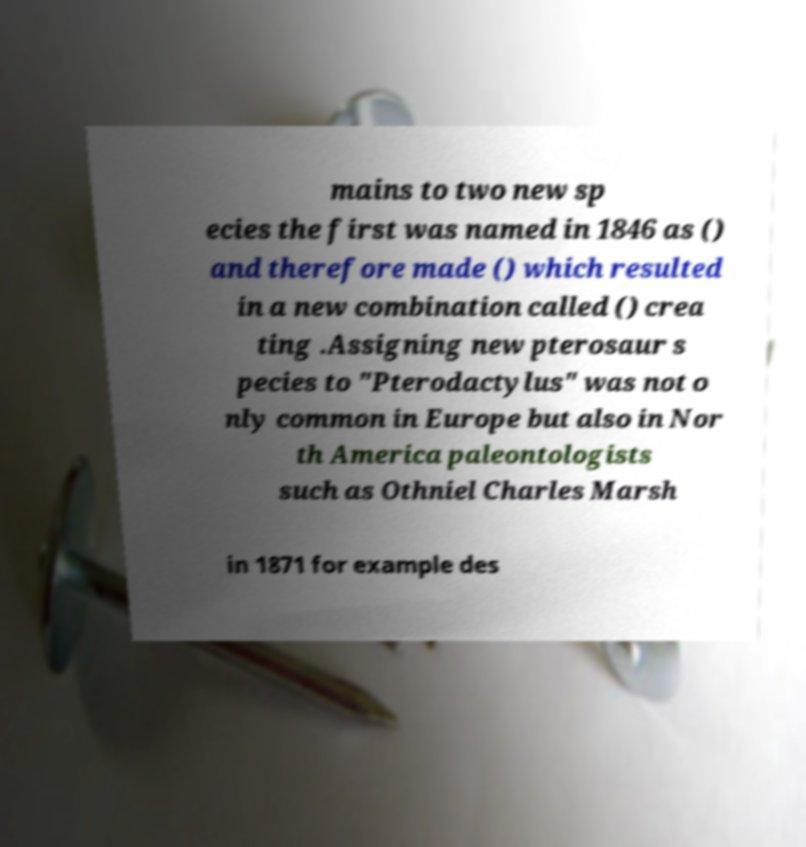I need the written content from this picture converted into text. Can you do that? mains to two new sp ecies the first was named in 1846 as () and therefore made () which resulted in a new combination called () crea ting .Assigning new pterosaur s pecies to "Pterodactylus" was not o nly common in Europe but also in Nor th America paleontologists such as Othniel Charles Marsh in 1871 for example des 